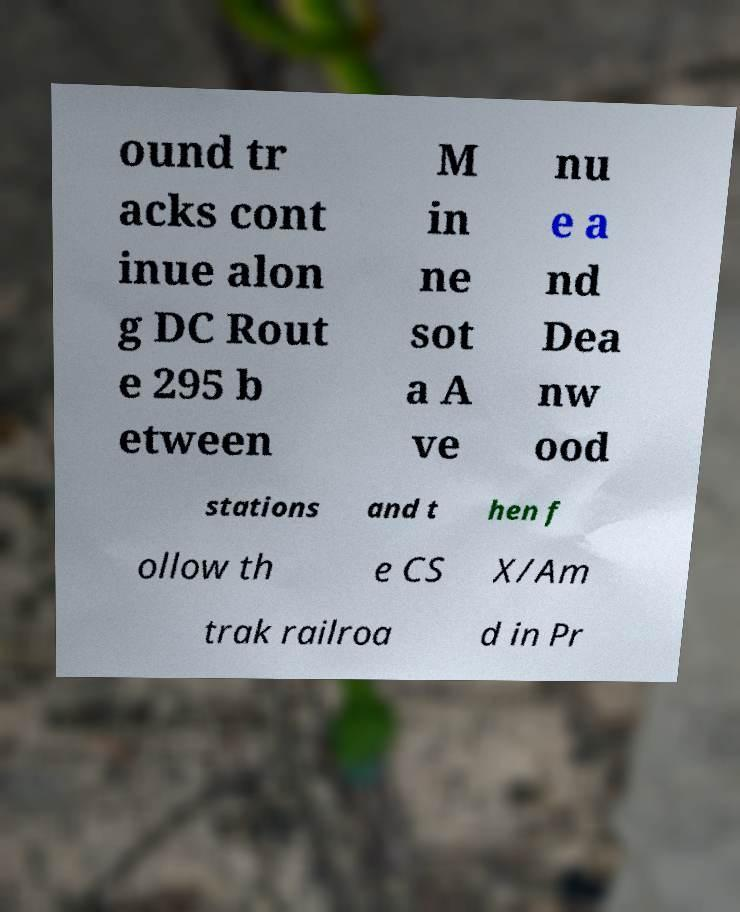Could you extract and type out the text from this image? ound tr acks cont inue alon g DC Rout e 295 b etween M in ne sot a A ve nu e a nd Dea nw ood stations and t hen f ollow th e CS X/Am trak railroa d in Pr 